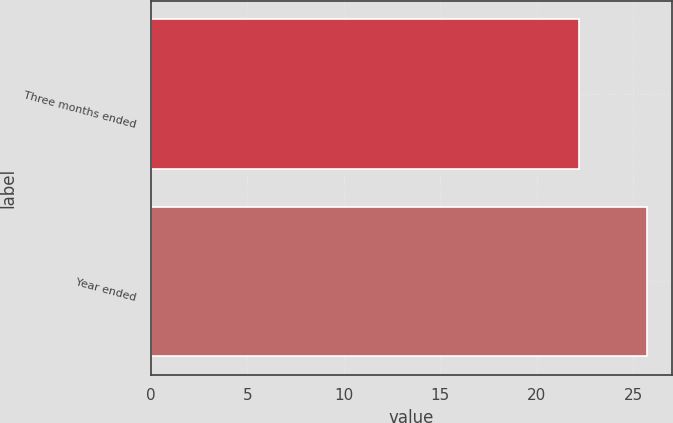<chart> <loc_0><loc_0><loc_500><loc_500><bar_chart><fcel>Three months ended<fcel>Year ended<nl><fcel>22.2<fcel>25.7<nl></chart> 